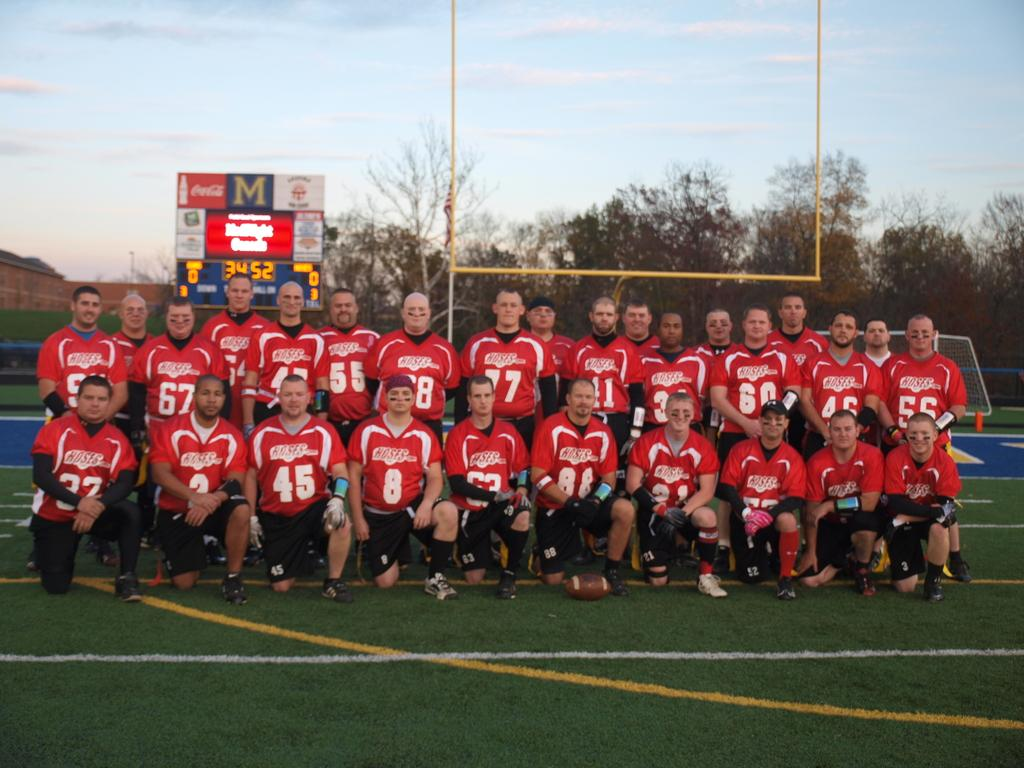<image>
Describe the image concisely. The Hoses football team takes a team picture in front of the Score board on the field. 